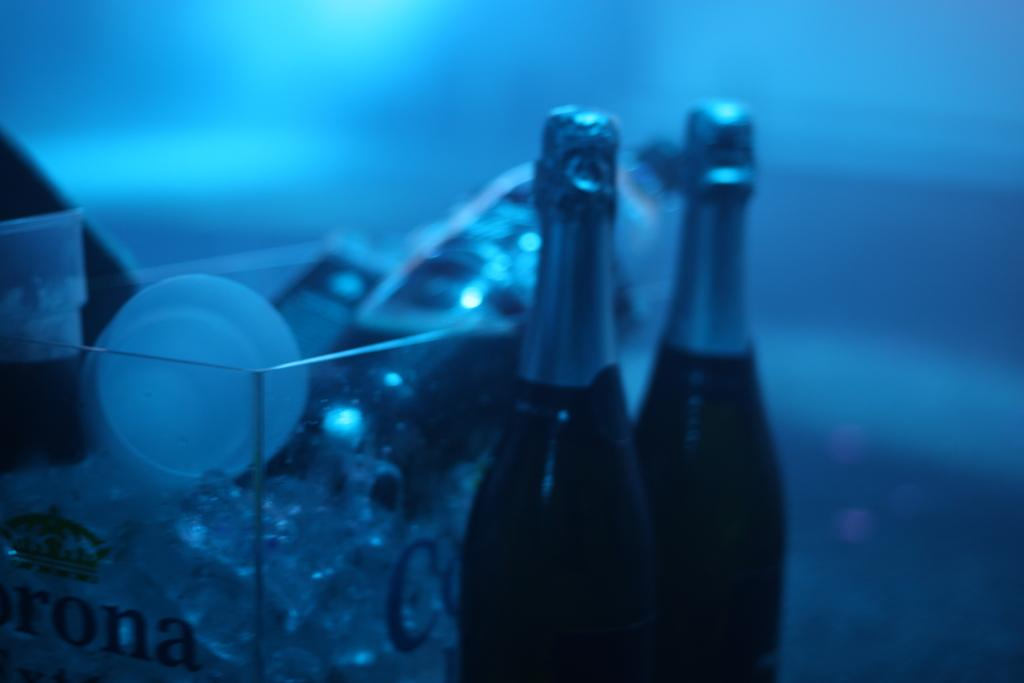<image>
Offer a succinct explanation of the picture presented. On a clear container, the letters "ona" can barely be seen. 